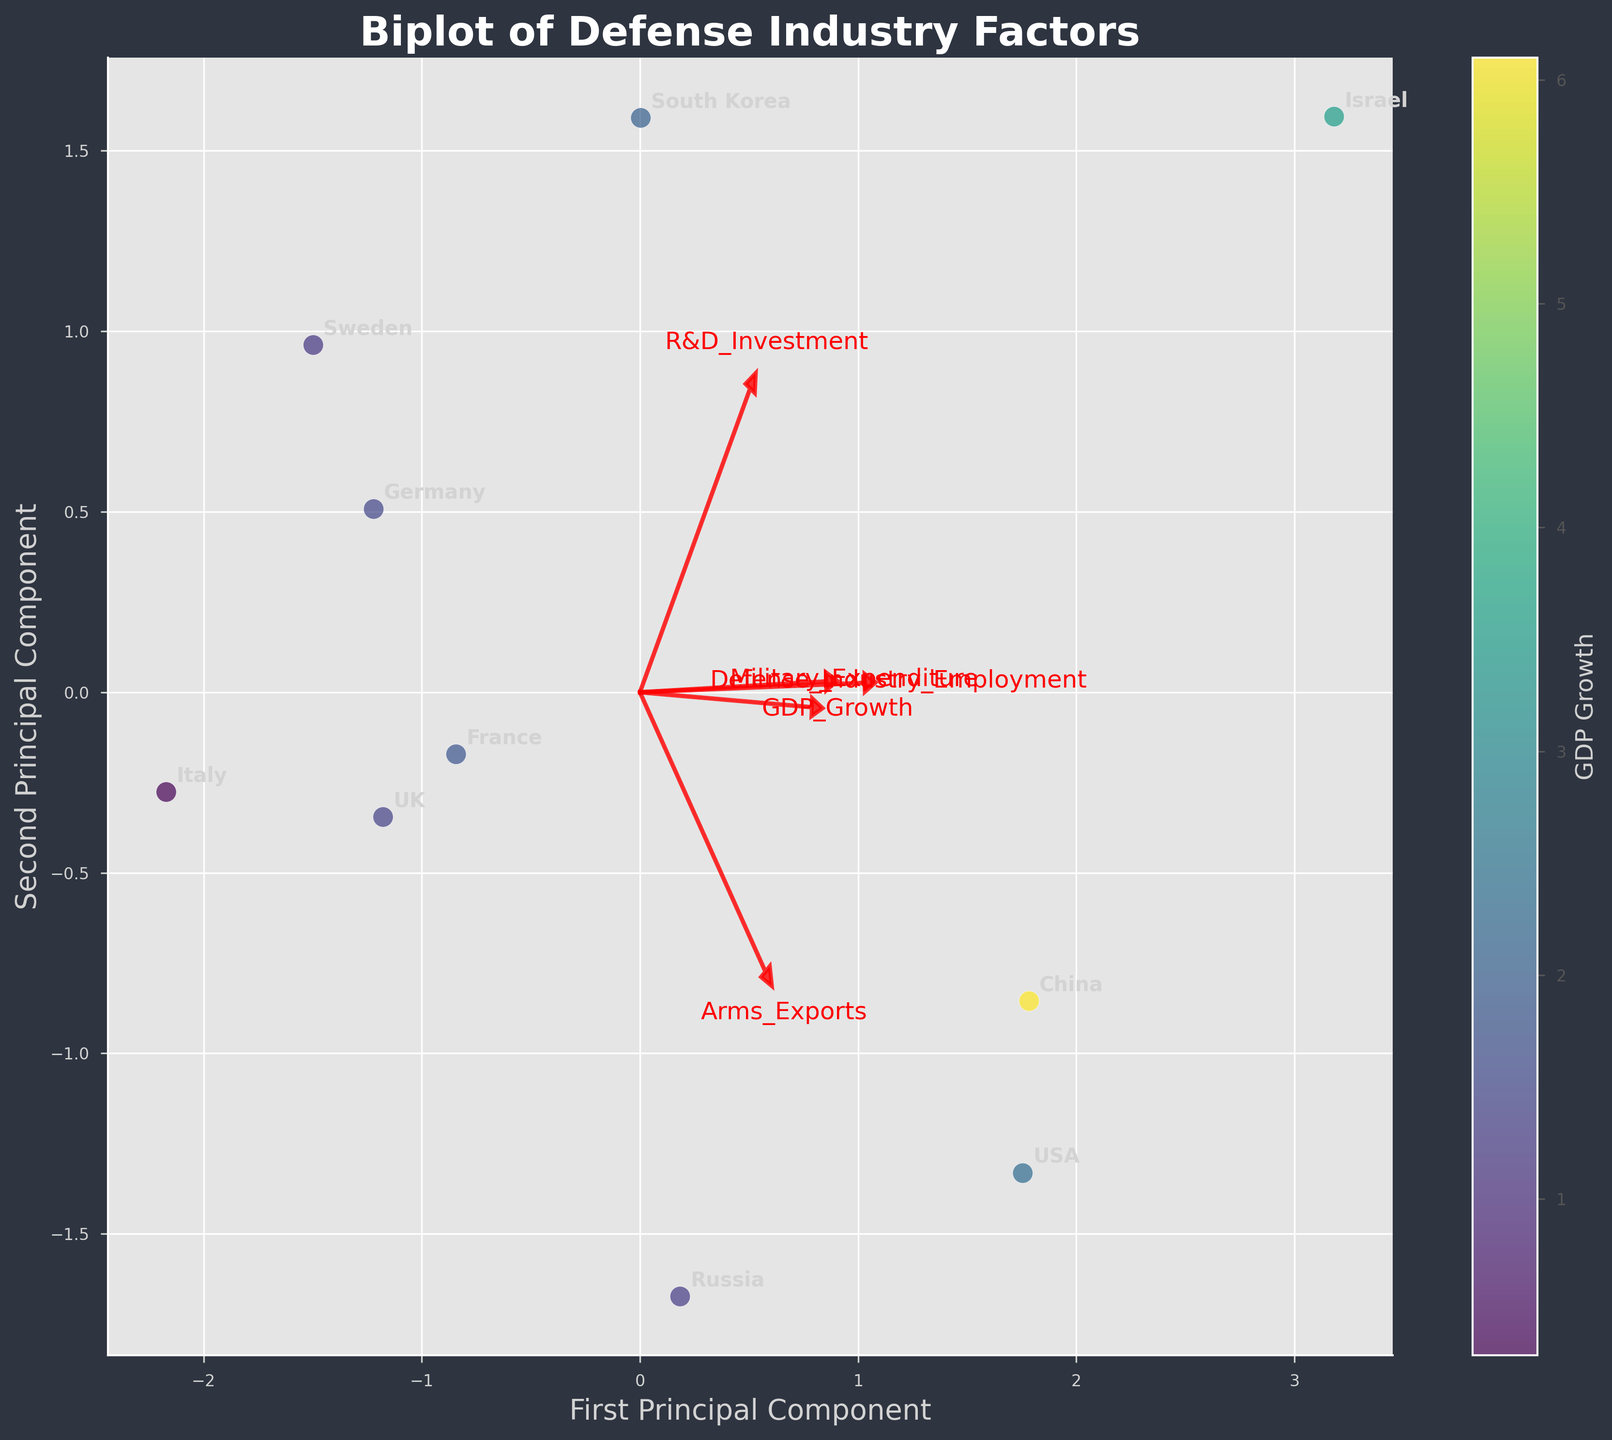Which component explains the most variance in the data? Look at the axes labeled 'First Principal Component' and 'Second Principal Component'. The component with the larger axis label is the one that explains the most variance. In this case, it's the 'First Principal Component'.
Answer: First Principal Component How many countries are represented in the plot? Count the number of distinct annotations on the biplot. Each annotation corresponds to a country. There are 10 countries shown.
Answer: 10 Which country has the highest GDP growth and where is it located on the plot? Identify the country with the highest value on the color scale representing GDP growth. The country with the highest GDP growth is China (6.1), and it is located in the upper right part of the plot.
Answer: China (upper right) Which variable seems to have the highest loading on the first principal component? Check the length and direction of the red arrows relative to the first principal component axis. The variable with the longest arrow along the first principal component direction is 'R&D_Investment'.
Answer: R&D_Investment Which two countries are most closely clustered together? Look for the pair of countries that are close to each other in the plot. The closest countries are France and UK.
Answer: France and UK Does the plot show any outlier in terms of defense industry employment? If so, which country is it? Identify the country that stands out in terms of position related to defense industry employment. The country Israel has the highest value (4.1) and is distanced from others horizontally.
Answer: Israel Which country has the lowest value for 'Arms_Exports' and where is it located on the plot? Identify the arrow direction associated with 'Arms_Exports' and locate the country farthest in the opposite direction. This point corresponds to Sweden.
Answer: Sweden Which variable appears to have the smallest contribution to the second principal component? Check the length of the red arrows along the second principal component axis. The variable 'Arms_Exports' has the smallest arrow length along this axis.
Answer: Arms_Exports How do 'Military_Expenditure' and 'Defense_Industry_Employment' correlate based on their loadings in the plot? Examine the direction of the red arrows representing these variables. Both arrows point in roughly the same direction, indicating a positive correlation between 'Military_Expenditure' and 'Defense_Industry_Employment'.
Answer: Positive correlation 